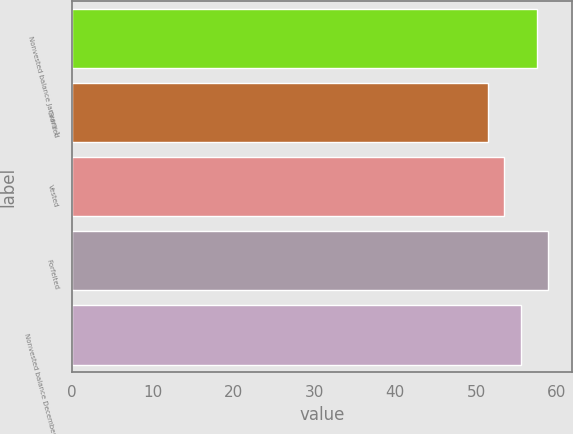Convert chart to OTSL. <chart><loc_0><loc_0><loc_500><loc_500><bar_chart><fcel>Nonvested balance January 1<fcel>Granted<fcel>Vested<fcel>Forfeited<fcel>Nonvested balance December 31<nl><fcel>57.51<fcel>51.5<fcel>53.5<fcel>58.97<fcel>55.55<nl></chart> 